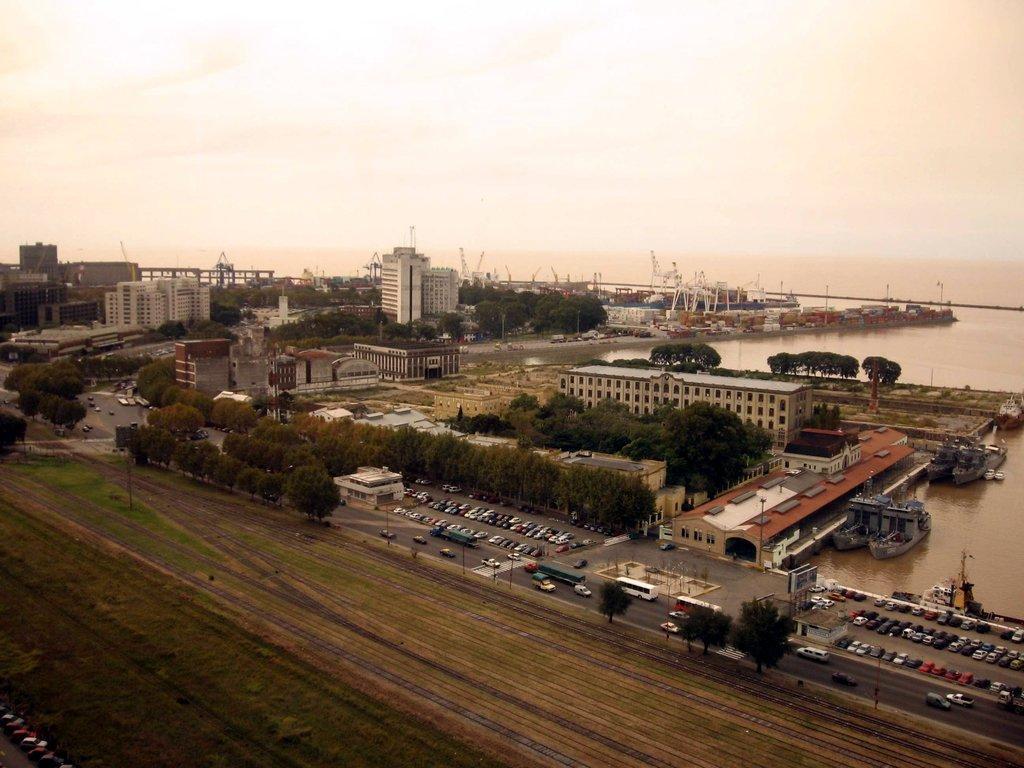Describe this image in one or two sentences. The picture is an aerial view of a city. In the foreground of the picture there are fields, cars, roads and buildings. In the center of the picture there are trees, buildings, boats and water. In the background there are buildings, trees and ships. Sky is cloudy. 